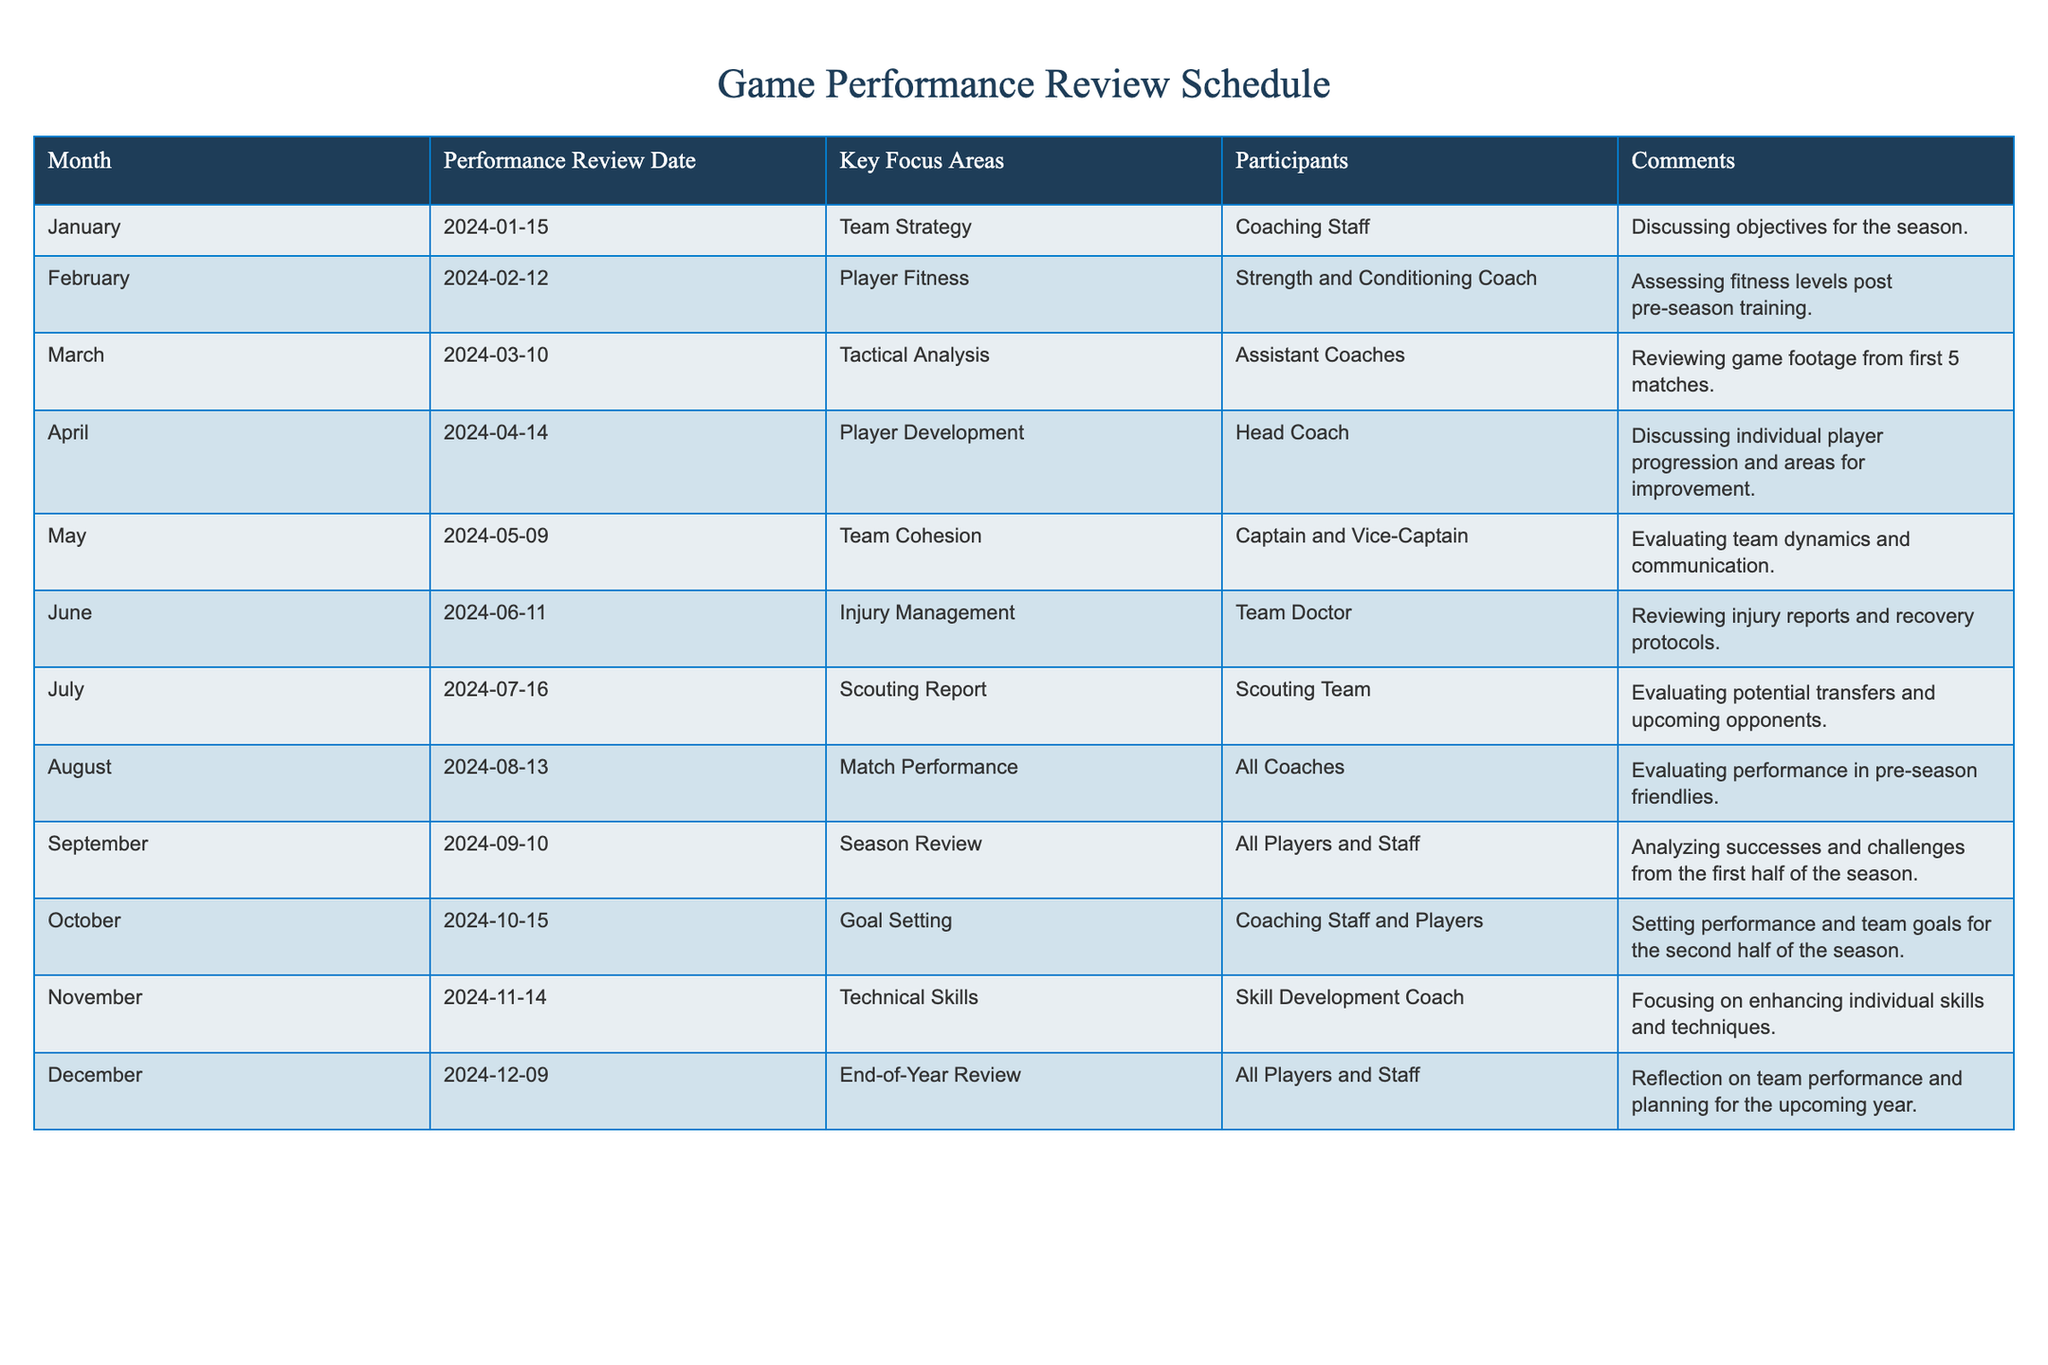What is the Performance Review Date for April? The table lists the Performance Review Dates for each month. Looking at the row for April, the date is 2024-04-14.
Answer: 2024-04-14 Which Key Focus Area is reviewed in June? According to the June row in the table, the Key Focus Area is Injury Management.
Answer: Injury Management How many participants are involved in the Season Review in September? In the September row, it states that all players and staff participate in the Season Review. This indicates that a comprehensive group is involved, but a specific numerical value isn't provided.
Answer: All Players and Staff What are the Key Focus Areas for the first quarter of the year? The first quarter consists of January, February, and March. For January, the Key Focus Area is Team Strategy; for February, it is Player Fitness; and for March, it is Tactical Analysis. Compiling these, the areas are Team Strategy, Player Fitness, and Tactical Analysis.
Answer: Team Strategy, Player Fitness, Tactical Analysis Is there a review focused on Technical Skills in the second half of the year? The table shows that there is a review focused on Technical Skills scheduled for November, which is in the second half of the year. Therefore, the statement is true.
Answer: Yes What is the difference in focus areas between October and November? In October, the focus area is Goal Setting, while in November, it is Technical Skills. The difference lies in the nature of the review: October aims at future objectives (Goal Setting), whereas November concentrates on improving existing abilities (Technical Skills).
Answer: Goal Setting vs. Technical Skills How many review dates fall in the second half of the year? The second half of the year includes July, August, September, October, November, and December. Counting these months, there are 6 Performance Review Dates that fall into this category.
Answer: 6 What is the last Performance Review Date of the year? The last Performance Review Date listed in the table is for December, which is on 2024-12-09. This date marks the end-of-year review.
Answer: 2024-12-09 Which month has the focus area related to Scouting Report? Referring to the table, July is the month designated for the Scouting Report as the Key Focus Area.
Answer: July 